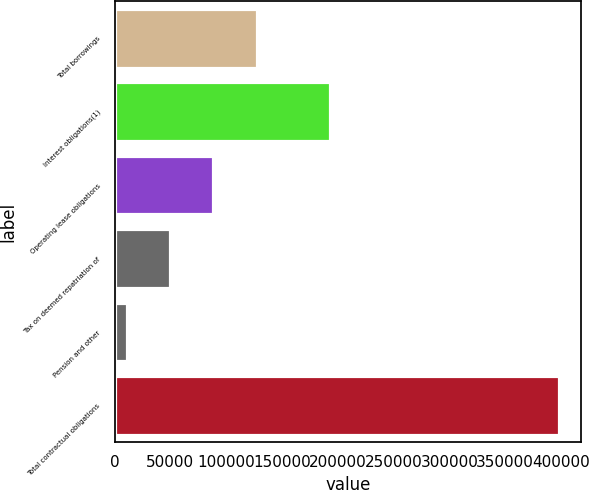Convert chart to OTSL. <chart><loc_0><loc_0><loc_500><loc_500><bar_chart><fcel>Total borrowings<fcel>Interest obligations(1)<fcel>Operating lease obligations<fcel>Tax on deemed repatriation of<fcel>Pension and other<fcel>Total contractual obligations<nl><fcel>127211<fcel>193220<fcel>88498.6<fcel>49785.8<fcel>11073<fcel>398201<nl></chart> 